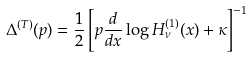Convert formula to latex. <formula><loc_0><loc_0><loc_500><loc_500>\Delta ^ { ( T ) } ( p ) = \frac { 1 } { 2 } \left [ p \frac { d } { d x } \log H _ { \nu } ^ { ( 1 ) } ( x ) + \kappa \right ] ^ { - 1 }</formula> 